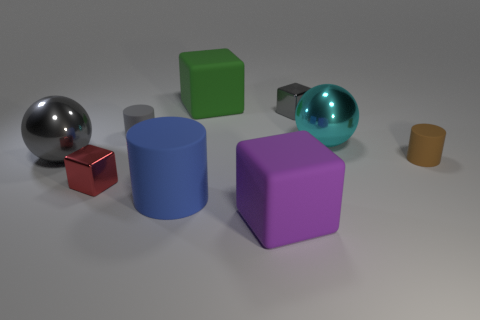There is another large thing that is the same shape as the brown thing; what is its color?
Your answer should be very brief. Blue. The object that is both in front of the gray ball and to the right of the big purple block is made of what material?
Your answer should be compact. Rubber. There is a sphere behind the gray metallic sphere; is it the same size as the large blue cylinder?
Make the answer very short. Yes. What material is the large purple object?
Offer a terse response. Rubber. What color is the large metal sphere that is on the right side of the blue cylinder?
Provide a succinct answer. Cyan. How many small objects are either gray objects or gray metal things?
Keep it short and to the point. 2. Does the small block behind the gray metal ball have the same color as the matte cylinder behind the gray metallic sphere?
Give a very brief answer. Yes. How many other things are there of the same color as the large rubber cylinder?
Provide a succinct answer. 0. How many blue things are either tiny rubber things or small metal cubes?
Keep it short and to the point. 0. Is the shape of the red metal object the same as the gray metal object that is behind the gray matte object?
Make the answer very short. Yes. 